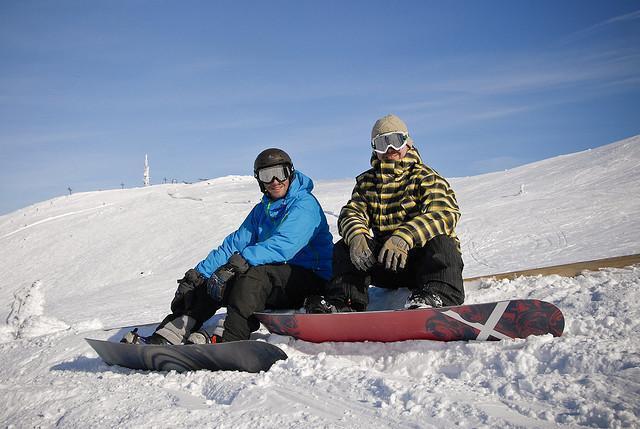How many people are shown?
Give a very brief answer. 2. How many people have gray goggles?
Give a very brief answer. 2. How many people are in the picture?
Give a very brief answer. 2. How many snowboards are there?
Give a very brief answer. 2. 